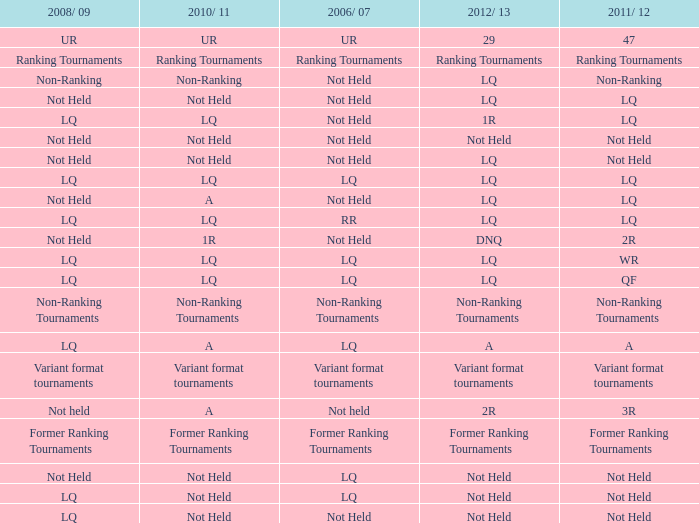What is 2006/07, when 2008/09 is LQ, and when 2010/11 is Not Held? LQ, Not Held. 